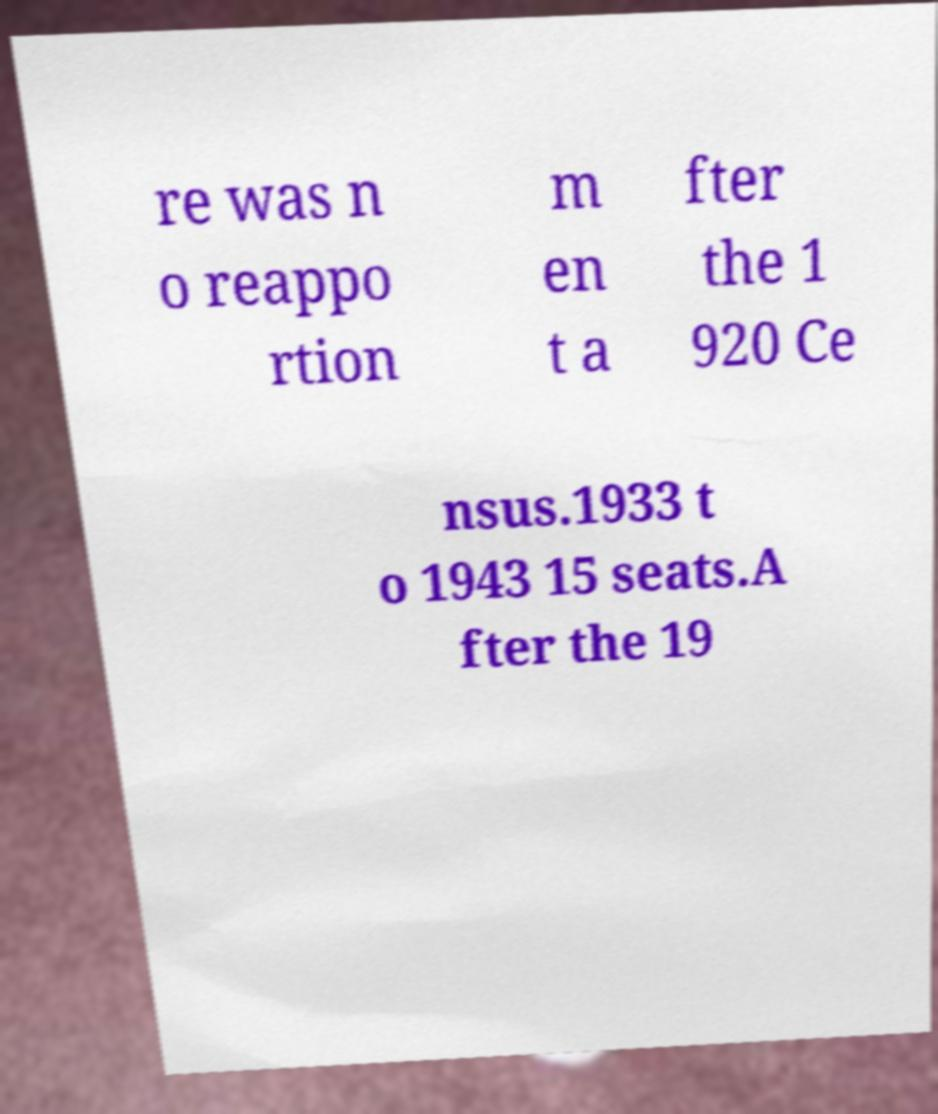Can you read and provide the text displayed in the image?This photo seems to have some interesting text. Can you extract and type it out for me? re was n o reappo rtion m en t a fter the 1 920 Ce nsus.1933 t o 1943 15 seats.A fter the 19 